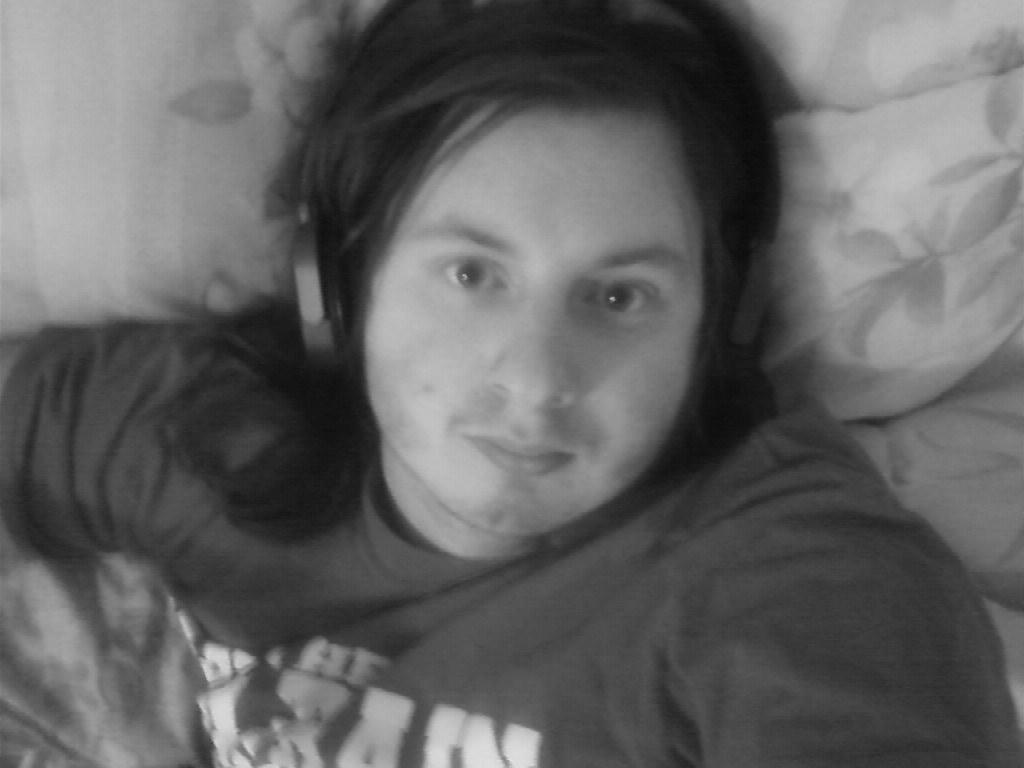What is the color scheme of the image? The image is black and white. What is the person in the image doing? The person is lying on the bed. What is the person using to support their head? The person has a pillow. What type of clothing is the person wearing? The person is wearing a shirt. What is the person using to listen to something? The person is wearing headphones. What type of wheel can be seen in the image? There is no wheel present in the image. How many beads are on the person's necklace in the image? The person is not wearing a necklace in the image. 